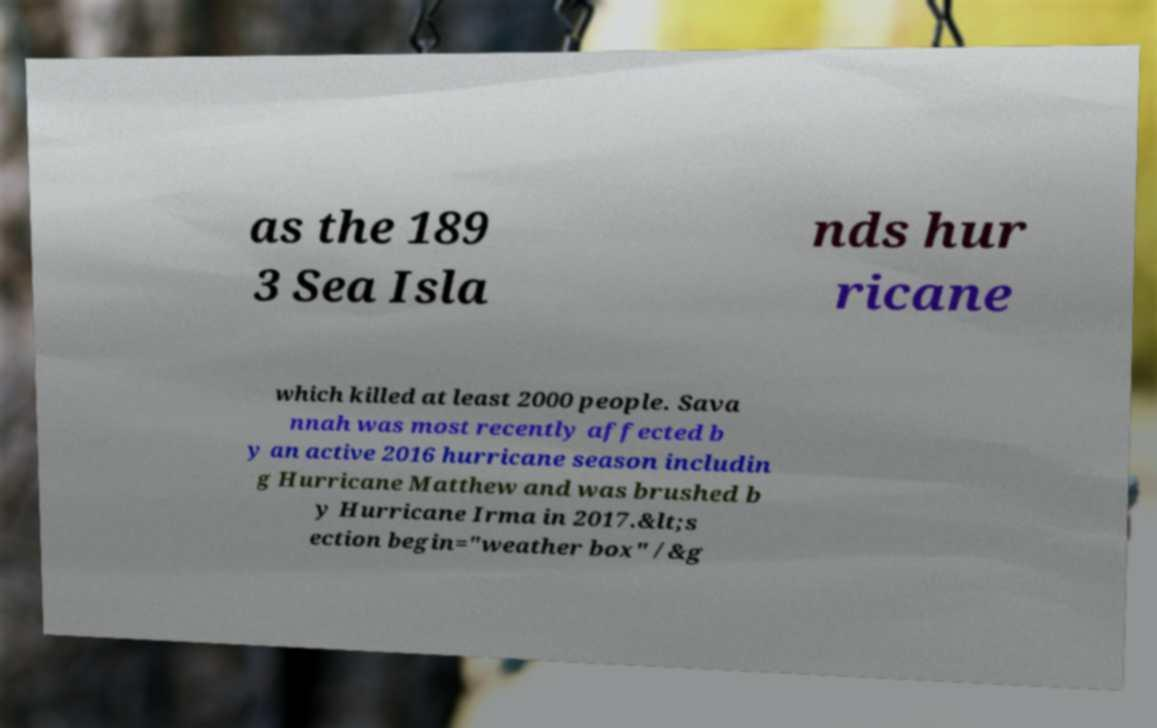Can you read and provide the text displayed in the image?This photo seems to have some interesting text. Can you extract and type it out for me? as the 189 3 Sea Isla nds hur ricane which killed at least 2000 people. Sava nnah was most recently affected b y an active 2016 hurricane season includin g Hurricane Matthew and was brushed b y Hurricane Irma in 2017.&lt;s ection begin="weather box" /&g 